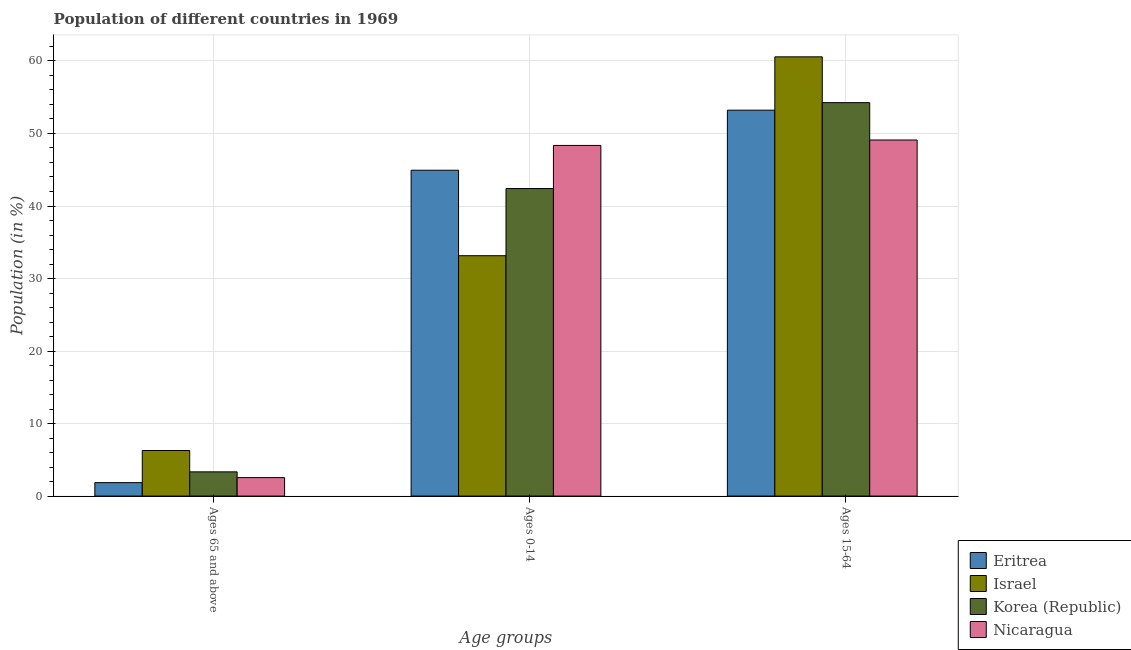How many different coloured bars are there?
Offer a very short reply. 4. How many bars are there on the 1st tick from the right?
Provide a short and direct response. 4. What is the label of the 2nd group of bars from the left?
Offer a very short reply. Ages 0-14. What is the percentage of population within the age-group of 65 and above in Nicaragua?
Make the answer very short. 2.54. Across all countries, what is the maximum percentage of population within the age-group 15-64?
Provide a short and direct response. 60.57. Across all countries, what is the minimum percentage of population within the age-group 15-64?
Your answer should be compact. 49.1. In which country was the percentage of population within the age-group of 65 and above maximum?
Make the answer very short. Israel. In which country was the percentage of population within the age-group of 65 and above minimum?
Your answer should be compact. Eritrea. What is the total percentage of population within the age-group 15-64 in the graph?
Make the answer very short. 217.14. What is the difference between the percentage of population within the age-group of 65 and above in Korea (Republic) and that in Nicaragua?
Ensure brevity in your answer.  0.79. What is the difference between the percentage of population within the age-group 0-14 in Korea (Republic) and the percentage of population within the age-group 15-64 in Nicaragua?
Offer a terse response. -6.69. What is the average percentage of population within the age-group 0-14 per country?
Your answer should be compact. 42.21. What is the difference between the percentage of population within the age-group of 65 and above and percentage of population within the age-group 15-64 in Korea (Republic)?
Provide a succinct answer. -50.91. In how many countries, is the percentage of population within the age-group of 65 and above greater than 54 %?
Provide a short and direct response. 0. What is the ratio of the percentage of population within the age-group of 65 and above in Korea (Republic) to that in Israel?
Provide a short and direct response. 0.53. Is the difference between the percentage of population within the age-group 15-64 in Korea (Republic) and Israel greater than the difference between the percentage of population within the age-group of 65 and above in Korea (Republic) and Israel?
Your response must be concise. No. What is the difference between the highest and the second highest percentage of population within the age-group 15-64?
Provide a succinct answer. 6.32. What is the difference between the highest and the lowest percentage of population within the age-group 0-14?
Make the answer very short. 15.21. What does the 3rd bar from the left in Ages 0-14 represents?
Make the answer very short. Korea (Republic). What does the 3rd bar from the right in Ages 0-14 represents?
Provide a succinct answer. Israel. Is it the case that in every country, the sum of the percentage of population within the age-group of 65 and above and percentage of population within the age-group 0-14 is greater than the percentage of population within the age-group 15-64?
Offer a very short reply. No. How many bars are there?
Your response must be concise. 12. Are the values on the major ticks of Y-axis written in scientific E-notation?
Keep it short and to the point. No. What is the title of the graph?
Your response must be concise. Population of different countries in 1969. Does "Suriname" appear as one of the legend labels in the graph?
Give a very brief answer. No. What is the label or title of the X-axis?
Your answer should be compact. Age groups. What is the Population (in %) of Eritrea in Ages 65 and above?
Provide a succinct answer. 1.85. What is the Population (in %) in Israel in Ages 65 and above?
Your answer should be compact. 6.28. What is the Population (in %) in Korea (Republic) in Ages 65 and above?
Make the answer very short. 3.34. What is the Population (in %) of Nicaragua in Ages 65 and above?
Your answer should be very brief. 2.54. What is the Population (in %) in Eritrea in Ages 0-14?
Keep it short and to the point. 44.93. What is the Population (in %) of Israel in Ages 0-14?
Keep it short and to the point. 33.15. What is the Population (in %) of Korea (Republic) in Ages 0-14?
Provide a succinct answer. 42.41. What is the Population (in %) of Nicaragua in Ages 0-14?
Your response must be concise. 48.35. What is the Population (in %) of Eritrea in Ages 15-64?
Offer a very short reply. 53.21. What is the Population (in %) of Israel in Ages 15-64?
Offer a very short reply. 60.57. What is the Population (in %) of Korea (Republic) in Ages 15-64?
Your answer should be very brief. 54.25. What is the Population (in %) of Nicaragua in Ages 15-64?
Offer a terse response. 49.1. Across all Age groups, what is the maximum Population (in %) in Eritrea?
Your answer should be compact. 53.21. Across all Age groups, what is the maximum Population (in %) in Israel?
Make the answer very short. 60.57. Across all Age groups, what is the maximum Population (in %) of Korea (Republic)?
Ensure brevity in your answer.  54.25. Across all Age groups, what is the maximum Population (in %) in Nicaragua?
Offer a terse response. 49.1. Across all Age groups, what is the minimum Population (in %) in Eritrea?
Your answer should be compact. 1.85. Across all Age groups, what is the minimum Population (in %) in Israel?
Offer a very short reply. 6.28. Across all Age groups, what is the minimum Population (in %) of Korea (Republic)?
Provide a short and direct response. 3.34. Across all Age groups, what is the minimum Population (in %) in Nicaragua?
Make the answer very short. 2.54. What is the total Population (in %) of Korea (Republic) in the graph?
Make the answer very short. 100. What is the difference between the Population (in %) in Eritrea in Ages 65 and above and that in Ages 0-14?
Make the answer very short. -43.08. What is the difference between the Population (in %) in Israel in Ages 65 and above and that in Ages 0-14?
Give a very brief answer. -26.86. What is the difference between the Population (in %) of Korea (Republic) in Ages 65 and above and that in Ages 0-14?
Ensure brevity in your answer.  -39.07. What is the difference between the Population (in %) in Nicaragua in Ages 65 and above and that in Ages 0-14?
Give a very brief answer. -45.81. What is the difference between the Population (in %) of Eritrea in Ages 65 and above and that in Ages 15-64?
Your response must be concise. -51.36. What is the difference between the Population (in %) in Israel in Ages 65 and above and that in Ages 15-64?
Keep it short and to the point. -54.29. What is the difference between the Population (in %) of Korea (Republic) in Ages 65 and above and that in Ages 15-64?
Give a very brief answer. -50.91. What is the difference between the Population (in %) of Nicaragua in Ages 65 and above and that in Ages 15-64?
Offer a very short reply. -46.56. What is the difference between the Population (in %) in Eritrea in Ages 0-14 and that in Ages 15-64?
Your response must be concise. -8.28. What is the difference between the Population (in %) in Israel in Ages 0-14 and that in Ages 15-64?
Offer a terse response. -27.42. What is the difference between the Population (in %) in Korea (Republic) in Ages 0-14 and that in Ages 15-64?
Your response must be concise. -11.84. What is the difference between the Population (in %) in Nicaragua in Ages 0-14 and that in Ages 15-64?
Ensure brevity in your answer.  -0.75. What is the difference between the Population (in %) of Eritrea in Ages 65 and above and the Population (in %) of Israel in Ages 0-14?
Make the answer very short. -31.29. What is the difference between the Population (in %) in Eritrea in Ages 65 and above and the Population (in %) in Korea (Republic) in Ages 0-14?
Ensure brevity in your answer.  -40.56. What is the difference between the Population (in %) in Eritrea in Ages 65 and above and the Population (in %) in Nicaragua in Ages 0-14?
Provide a short and direct response. -46.5. What is the difference between the Population (in %) in Israel in Ages 65 and above and the Population (in %) in Korea (Republic) in Ages 0-14?
Your answer should be compact. -36.13. What is the difference between the Population (in %) of Israel in Ages 65 and above and the Population (in %) of Nicaragua in Ages 0-14?
Offer a terse response. -42.07. What is the difference between the Population (in %) of Korea (Republic) in Ages 65 and above and the Population (in %) of Nicaragua in Ages 0-14?
Your answer should be very brief. -45.01. What is the difference between the Population (in %) of Eritrea in Ages 65 and above and the Population (in %) of Israel in Ages 15-64?
Give a very brief answer. -58.72. What is the difference between the Population (in %) in Eritrea in Ages 65 and above and the Population (in %) in Korea (Republic) in Ages 15-64?
Make the answer very short. -52.4. What is the difference between the Population (in %) of Eritrea in Ages 65 and above and the Population (in %) of Nicaragua in Ages 15-64?
Keep it short and to the point. -47.25. What is the difference between the Population (in %) in Israel in Ages 65 and above and the Population (in %) in Korea (Republic) in Ages 15-64?
Provide a succinct answer. -47.97. What is the difference between the Population (in %) in Israel in Ages 65 and above and the Population (in %) in Nicaragua in Ages 15-64?
Offer a terse response. -42.82. What is the difference between the Population (in %) of Korea (Republic) in Ages 65 and above and the Population (in %) of Nicaragua in Ages 15-64?
Offer a terse response. -45.76. What is the difference between the Population (in %) in Eritrea in Ages 0-14 and the Population (in %) in Israel in Ages 15-64?
Your response must be concise. -15.64. What is the difference between the Population (in %) in Eritrea in Ages 0-14 and the Population (in %) in Korea (Republic) in Ages 15-64?
Offer a very short reply. -9.32. What is the difference between the Population (in %) of Eritrea in Ages 0-14 and the Population (in %) of Nicaragua in Ages 15-64?
Provide a succinct answer. -4.17. What is the difference between the Population (in %) of Israel in Ages 0-14 and the Population (in %) of Korea (Republic) in Ages 15-64?
Your answer should be compact. -21.11. What is the difference between the Population (in %) of Israel in Ages 0-14 and the Population (in %) of Nicaragua in Ages 15-64?
Make the answer very short. -15.96. What is the difference between the Population (in %) in Korea (Republic) in Ages 0-14 and the Population (in %) in Nicaragua in Ages 15-64?
Offer a terse response. -6.69. What is the average Population (in %) of Eritrea per Age groups?
Keep it short and to the point. 33.33. What is the average Population (in %) of Israel per Age groups?
Your response must be concise. 33.33. What is the average Population (in %) of Korea (Republic) per Age groups?
Make the answer very short. 33.33. What is the average Population (in %) of Nicaragua per Age groups?
Your answer should be compact. 33.33. What is the difference between the Population (in %) of Eritrea and Population (in %) of Israel in Ages 65 and above?
Ensure brevity in your answer.  -4.43. What is the difference between the Population (in %) in Eritrea and Population (in %) in Korea (Republic) in Ages 65 and above?
Your response must be concise. -1.49. What is the difference between the Population (in %) in Eritrea and Population (in %) in Nicaragua in Ages 65 and above?
Ensure brevity in your answer.  -0.69. What is the difference between the Population (in %) in Israel and Population (in %) in Korea (Republic) in Ages 65 and above?
Make the answer very short. 2.95. What is the difference between the Population (in %) in Israel and Population (in %) in Nicaragua in Ages 65 and above?
Give a very brief answer. 3.74. What is the difference between the Population (in %) of Korea (Republic) and Population (in %) of Nicaragua in Ages 65 and above?
Offer a very short reply. 0.79. What is the difference between the Population (in %) of Eritrea and Population (in %) of Israel in Ages 0-14?
Offer a very short reply. 11.79. What is the difference between the Population (in %) of Eritrea and Population (in %) of Korea (Republic) in Ages 0-14?
Provide a short and direct response. 2.52. What is the difference between the Population (in %) of Eritrea and Population (in %) of Nicaragua in Ages 0-14?
Keep it short and to the point. -3.42. What is the difference between the Population (in %) of Israel and Population (in %) of Korea (Republic) in Ages 0-14?
Give a very brief answer. -9.26. What is the difference between the Population (in %) in Israel and Population (in %) in Nicaragua in Ages 0-14?
Your answer should be very brief. -15.21. What is the difference between the Population (in %) in Korea (Republic) and Population (in %) in Nicaragua in Ages 0-14?
Your response must be concise. -5.94. What is the difference between the Population (in %) in Eritrea and Population (in %) in Israel in Ages 15-64?
Keep it short and to the point. -7.36. What is the difference between the Population (in %) in Eritrea and Population (in %) in Korea (Republic) in Ages 15-64?
Your response must be concise. -1.04. What is the difference between the Population (in %) of Eritrea and Population (in %) of Nicaragua in Ages 15-64?
Your answer should be compact. 4.11. What is the difference between the Population (in %) of Israel and Population (in %) of Korea (Republic) in Ages 15-64?
Provide a short and direct response. 6.32. What is the difference between the Population (in %) of Israel and Population (in %) of Nicaragua in Ages 15-64?
Your response must be concise. 11.47. What is the difference between the Population (in %) of Korea (Republic) and Population (in %) of Nicaragua in Ages 15-64?
Give a very brief answer. 5.15. What is the ratio of the Population (in %) of Eritrea in Ages 65 and above to that in Ages 0-14?
Offer a terse response. 0.04. What is the ratio of the Population (in %) of Israel in Ages 65 and above to that in Ages 0-14?
Provide a succinct answer. 0.19. What is the ratio of the Population (in %) in Korea (Republic) in Ages 65 and above to that in Ages 0-14?
Keep it short and to the point. 0.08. What is the ratio of the Population (in %) of Nicaragua in Ages 65 and above to that in Ages 0-14?
Provide a succinct answer. 0.05. What is the ratio of the Population (in %) of Eritrea in Ages 65 and above to that in Ages 15-64?
Keep it short and to the point. 0.03. What is the ratio of the Population (in %) of Israel in Ages 65 and above to that in Ages 15-64?
Your response must be concise. 0.1. What is the ratio of the Population (in %) in Korea (Republic) in Ages 65 and above to that in Ages 15-64?
Provide a succinct answer. 0.06. What is the ratio of the Population (in %) of Nicaragua in Ages 65 and above to that in Ages 15-64?
Your answer should be compact. 0.05. What is the ratio of the Population (in %) in Eritrea in Ages 0-14 to that in Ages 15-64?
Give a very brief answer. 0.84. What is the ratio of the Population (in %) of Israel in Ages 0-14 to that in Ages 15-64?
Your response must be concise. 0.55. What is the ratio of the Population (in %) of Korea (Republic) in Ages 0-14 to that in Ages 15-64?
Your answer should be compact. 0.78. What is the ratio of the Population (in %) in Nicaragua in Ages 0-14 to that in Ages 15-64?
Provide a succinct answer. 0.98. What is the difference between the highest and the second highest Population (in %) in Eritrea?
Offer a very short reply. 8.28. What is the difference between the highest and the second highest Population (in %) in Israel?
Make the answer very short. 27.42. What is the difference between the highest and the second highest Population (in %) of Korea (Republic)?
Ensure brevity in your answer.  11.84. What is the difference between the highest and the second highest Population (in %) of Nicaragua?
Your answer should be very brief. 0.75. What is the difference between the highest and the lowest Population (in %) of Eritrea?
Make the answer very short. 51.36. What is the difference between the highest and the lowest Population (in %) of Israel?
Give a very brief answer. 54.29. What is the difference between the highest and the lowest Population (in %) in Korea (Republic)?
Provide a short and direct response. 50.91. What is the difference between the highest and the lowest Population (in %) in Nicaragua?
Ensure brevity in your answer.  46.56. 